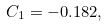<formula> <loc_0><loc_0><loc_500><loc_500>C _ { 1 } = - 0 . 1 8 2 ,</formula> 